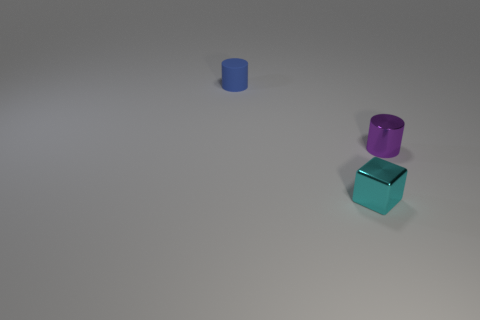How many cyan blocks are on the right side of the tiny matte cylinder?
Provide a succinct answer. 1. Is the number of tiny blue things greater than the number of large gray metallic blocks?
Your answer should be compact. Yes. There is a object that is both behind the small cyan metal block and right of the blue matte cylinder; what is its shape?
Your answer should be compact. Cylinder. Is there a cyan rubber object?
Your response must be concise. No. There is a tiny purple thing that is the same shape as the tiny blue thing; what is it made of?
Ensure brevity in your answer.  Metal. There is a shiny object that is behind the tiny shiny object in front of the tiny cylinder to the right of the blue cylinder; what shape is it?
Provide a succinct answer. Cylinder. How many other matte things are the same shape as the tiny blue matte object?
Offer a very short reply. 0. There is a small object in front of the small purple thing; is its color the same as the cylinder that is to the left of the purple shiny thing?
Ensure brevity in your answer.  No. What material is the cylinder that is the same size as the purple thing?
Provide a succinct answer. Rubber. Is there another matte object of the same size as the blue matte thing?
Provide a short and direct response. No. 